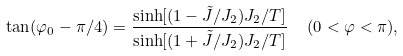<formula> <loc_0><loc_0><loc_500><loc_500>\tan ( \varphi _ { 0 } - \pi / 4 ) = { \frac { \sinh [ ( 1 - \tilde { J } / J _ { 2 } ) J _ { 2 } / T ] } { \sinh [ ( 1 + \tilde { J } / J _ { 2 } ) J _ { 2 } / T ] } } \ \ ( 0 < \varphi < \pi ) ,</formula> 